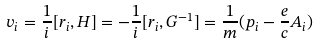Convert formula to latex. <formula><loc_0><loc_0><loc_500><loc_500>v _ { i } = \frac { 1 } { i } [ r _ { i } , H ] = - \frac { 1 } { i } [ r _ { i } , G ^ { - 1 } ] = \frac { 1 } { m } ( p _ { i } - \frac { e } { c } A _ { i } )</formula> 